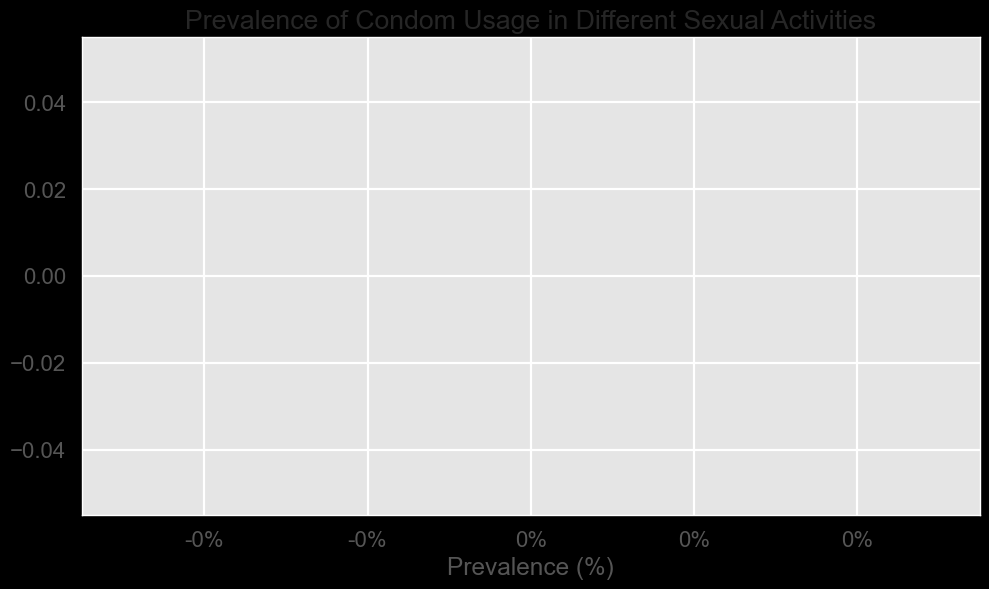What's the activity with the highest prevalence of condom usage? Look at the bar chart and identify which bar is the longest, signifying the highest percentage.
Answer: [Activity with highest prevalence] What's the difference in condom usage prevalence between [Highest Activity] and [Second Highest Activity]? The highest activity's prevalence is X%, and the second highest is Y%. Subtract Y from X to get the difference.
Answer: X - Y% What's the average prevalence of condom usage across all listed activities? Sum all the prevalence percentages and then divide by the number of activities. (P1 + P2 + ... + Pn) / n
Answer: Average percentage Which activity has the lowest prevalence of condom usage? Identify the shortest bar in the bar chart which represents the lowest percentage.
Answer: [Activity with lowest prevalence] Compare the prevalence between [Activity A] and [Activity B]. Which one is greater? Look at the lengths of bars for Activity A and Activity B. The longer bar indicates a greater prevalence.
Answer: [Activity with greater prevalence] What's the combined prevalence of condom usage for [Activity A] and [Activity B]? Add the prevalence percentages of Activity A and Activity B.
Answer: A% + B% What is the median value of condom usage prevalence? List all prevalence values in ascending order and find the middle value. If there are an even number of activities, take the average of the two middle values.
Answer: Median percentage How many activities have a prevalence rate greater than X%? Count the number of bars that extend beyond the X% mark on the x-axis.
Answer: [Number] What percent more prevalent is condom usage in [Activity A] compared to [Activity B]? Take the prevalence of Activity A, subtract B from A, and then divide the result by B. Multiply the result by 100.
Answer: ((A - B) / B) * 100% Which activities have a prevalence rate close to the average? Calculate the average prevalence rate, then identify the bars which are within a small range (e.g., ±2%) of this average.
Answer: [Activities close to average] 